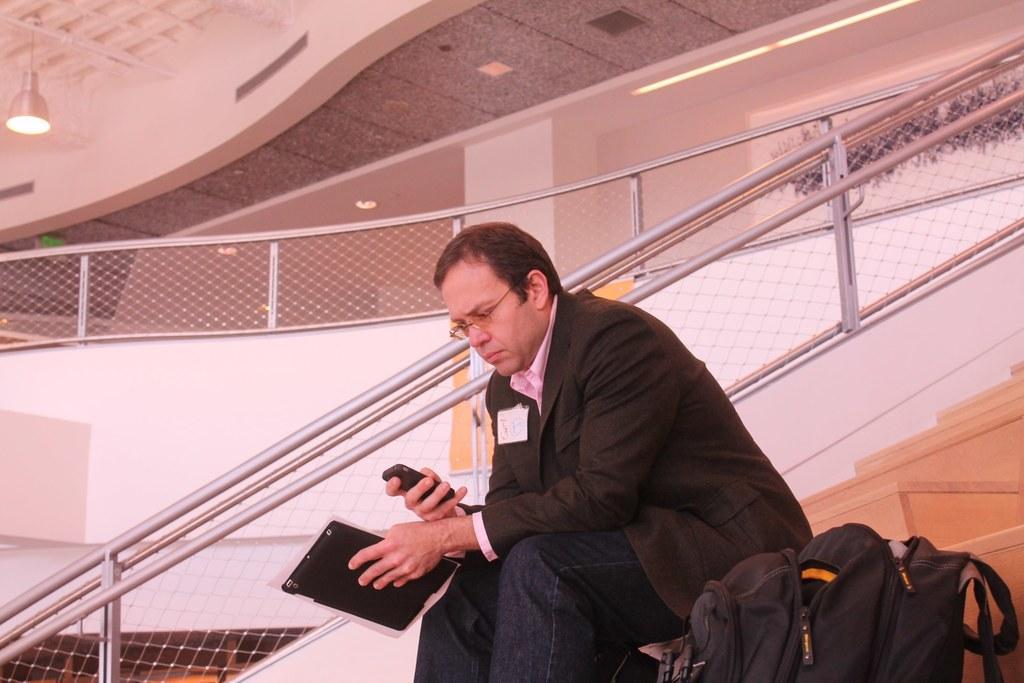How would you summarize this image in a sentence or two? In this picture we can see a man is sitting and holding a mobile phone and a file, there is a bag at the bottom, on the right side there are stars, we can see metal rods in the middle, there is a light at the left top of the picture. 